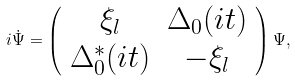Convert formula to latex. <formula><loc_0><loc_0><loc_500><loc_500>i \dot { \Psi } = \left ( \begin{array} { c c } \xi _ { l } & \Delta _ { 0 } ( i t ) \\ { \Delta _ { 0 } ^ { * } ( i t ) } & - \xi _ { l } \end{array} \right ) \Psi ,</formula> 